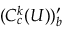<formula> <loc_0><loc_0><loc_500><loc_500>( C _ { c } ^ { k } ( U ) ) _ { b } ^ { \prime }</formula> 